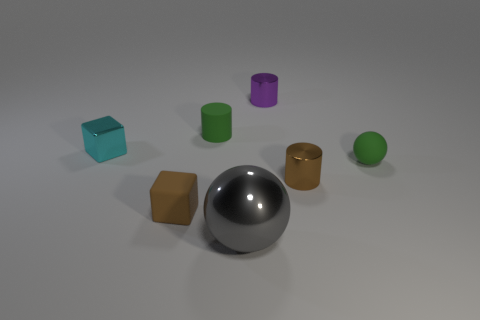Add 2 brown cubes. How many objects exist? 9 Subtract all balls. How many objects are left? 5 Subtract 0 yellow spheres. How many objects are left? 7 Subtract all tiny green matte cylinders. Subtract all cylinders. How many objects are left? 3 Add 4 cyan metallic objects. How many cyan metallic objects are left? 5 Add 3 large red rubber objects. How many large red rubber objects exist? 3 